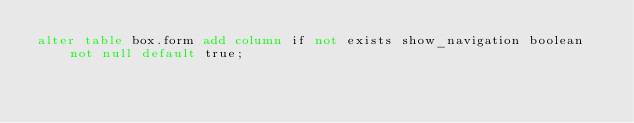<code> <loc_0><loc_0><loc_500><loc_500><_SQL_>alter table box.form add column if not exists show_navigation boolean not null default true;</code> 